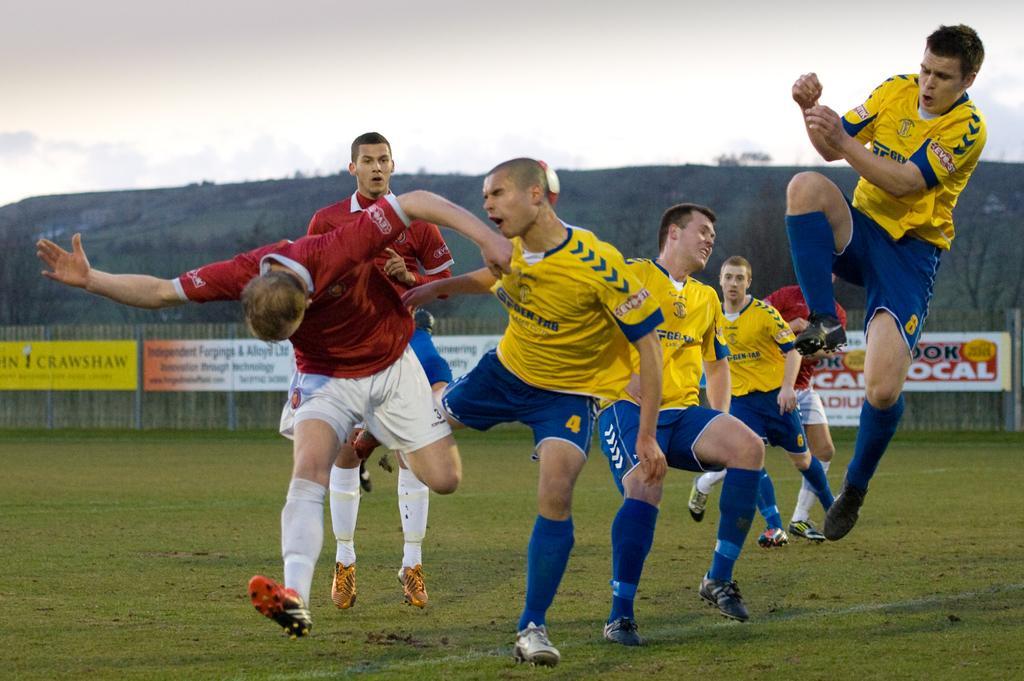Can you describe this image briefly? In this image we can see a group of people playing on the ground, behind them there is a fence with some boards, also there are mountains covered with trees and above that there is a sky. 